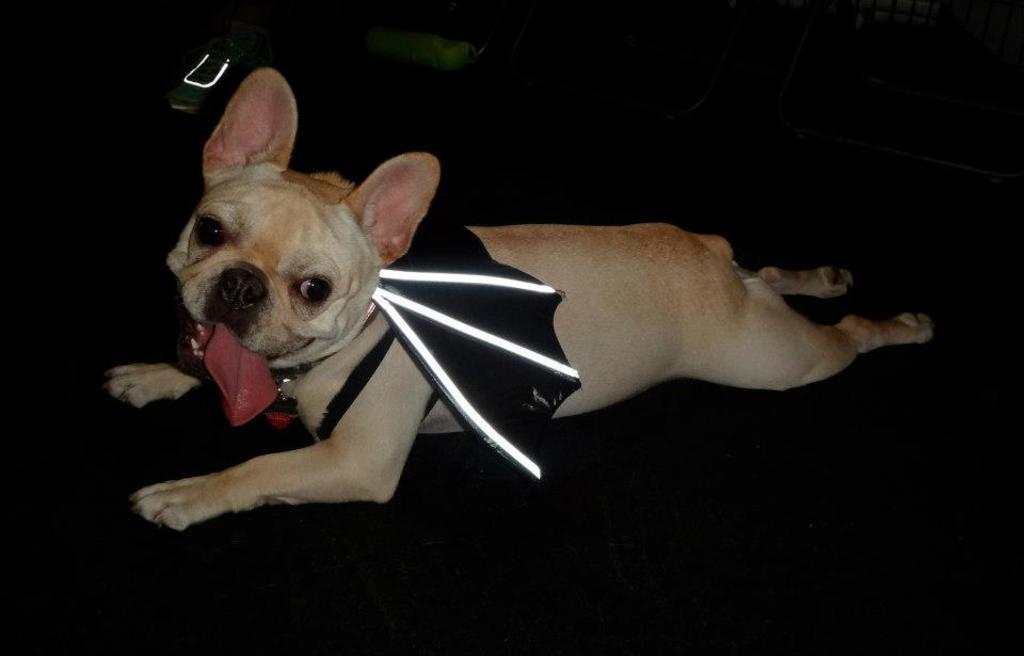What animal is present in the image? There is a dog in the image. What is the dog doing in the image? The dog is lying down in the image. What color is the surface the dog is lying on? The surface the dog is lying on is black in color. How many light bulbs are hanging above the dog in the image? There are no light bulbs present in the image; it only features a dog lying on a black surface. 